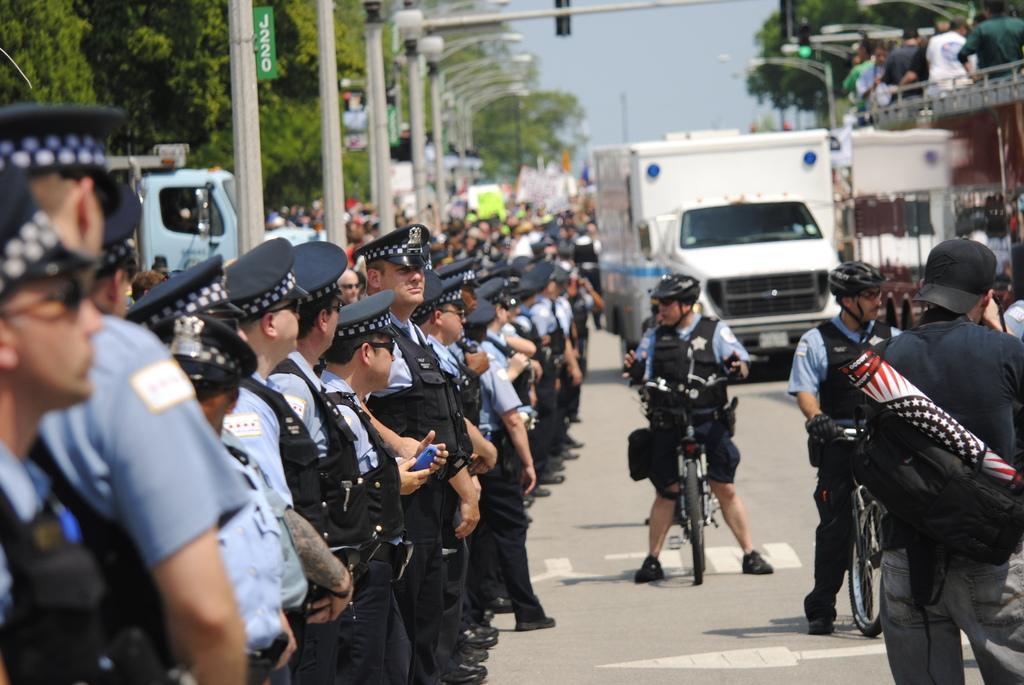Could you give a brief overview of what you see in this image? In this image, In the left side there some people standing, In the middle there is a man standing on a bicycle, In the right side there are some people standing and there is a white color truck, In the left side there are some white color poles and there are some trees in green color. 